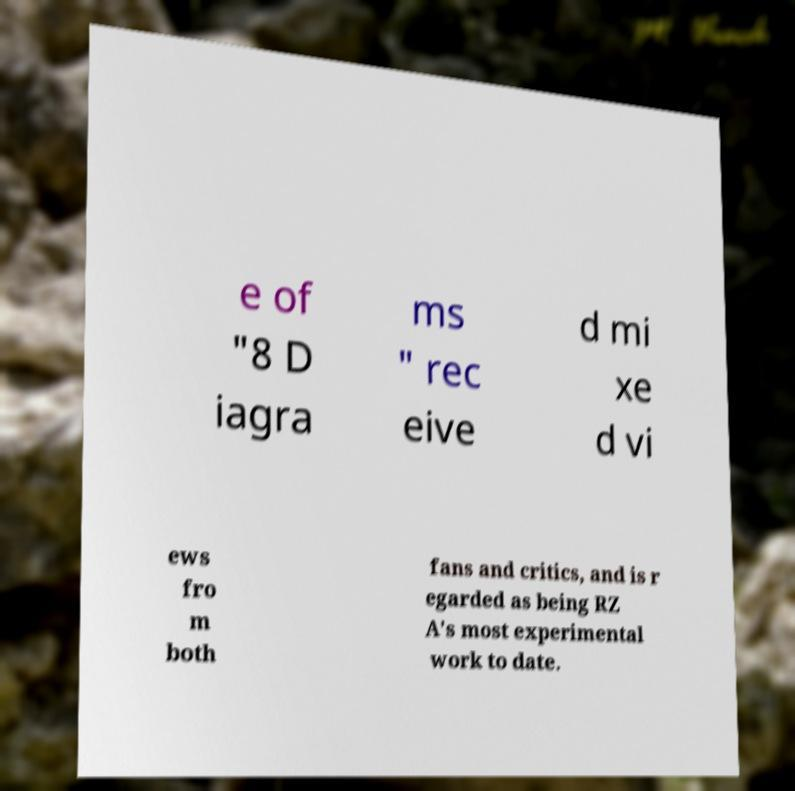Could you assist in decoding the text presented in this image and type it out clearly? e of "8 D iagra ms " rec eive d mi xe d vi ews fro m both fans and critics, and is r egarded as being RZ A's most experimental work to date. 